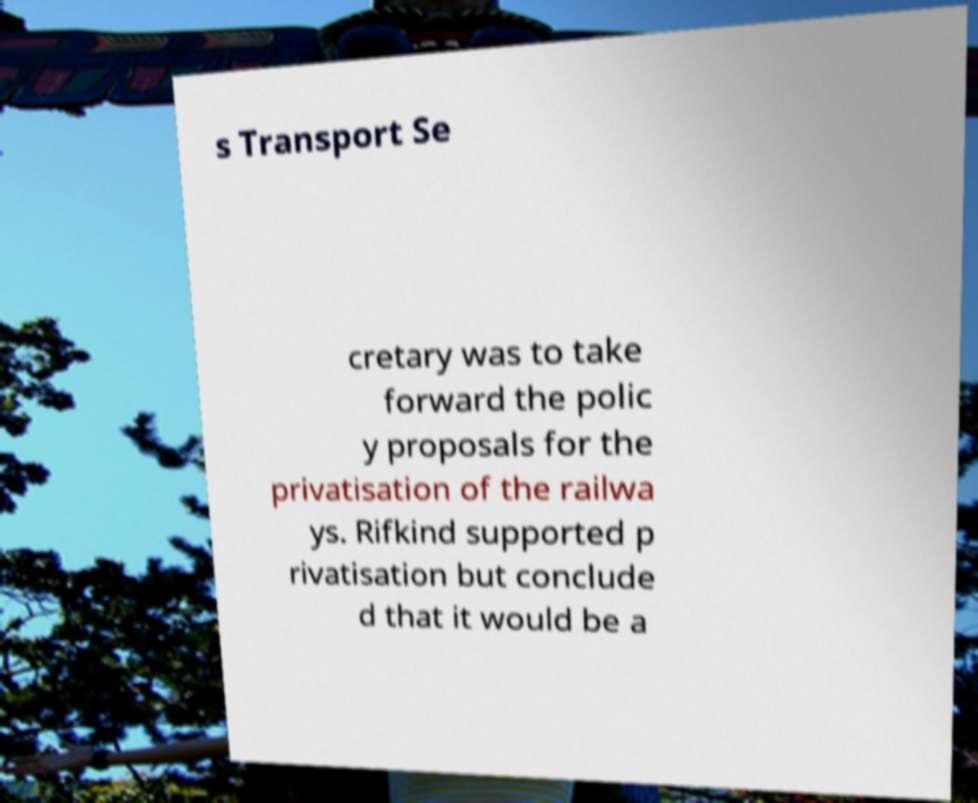For documentation purposes, I need the text within this image transcribed. Could you provide that? s Transport Se cretary was to take forward the polic y proposals for the privatisation of the railwa ys. Rifkind supported p rivatisation but conclude d that it would be a 